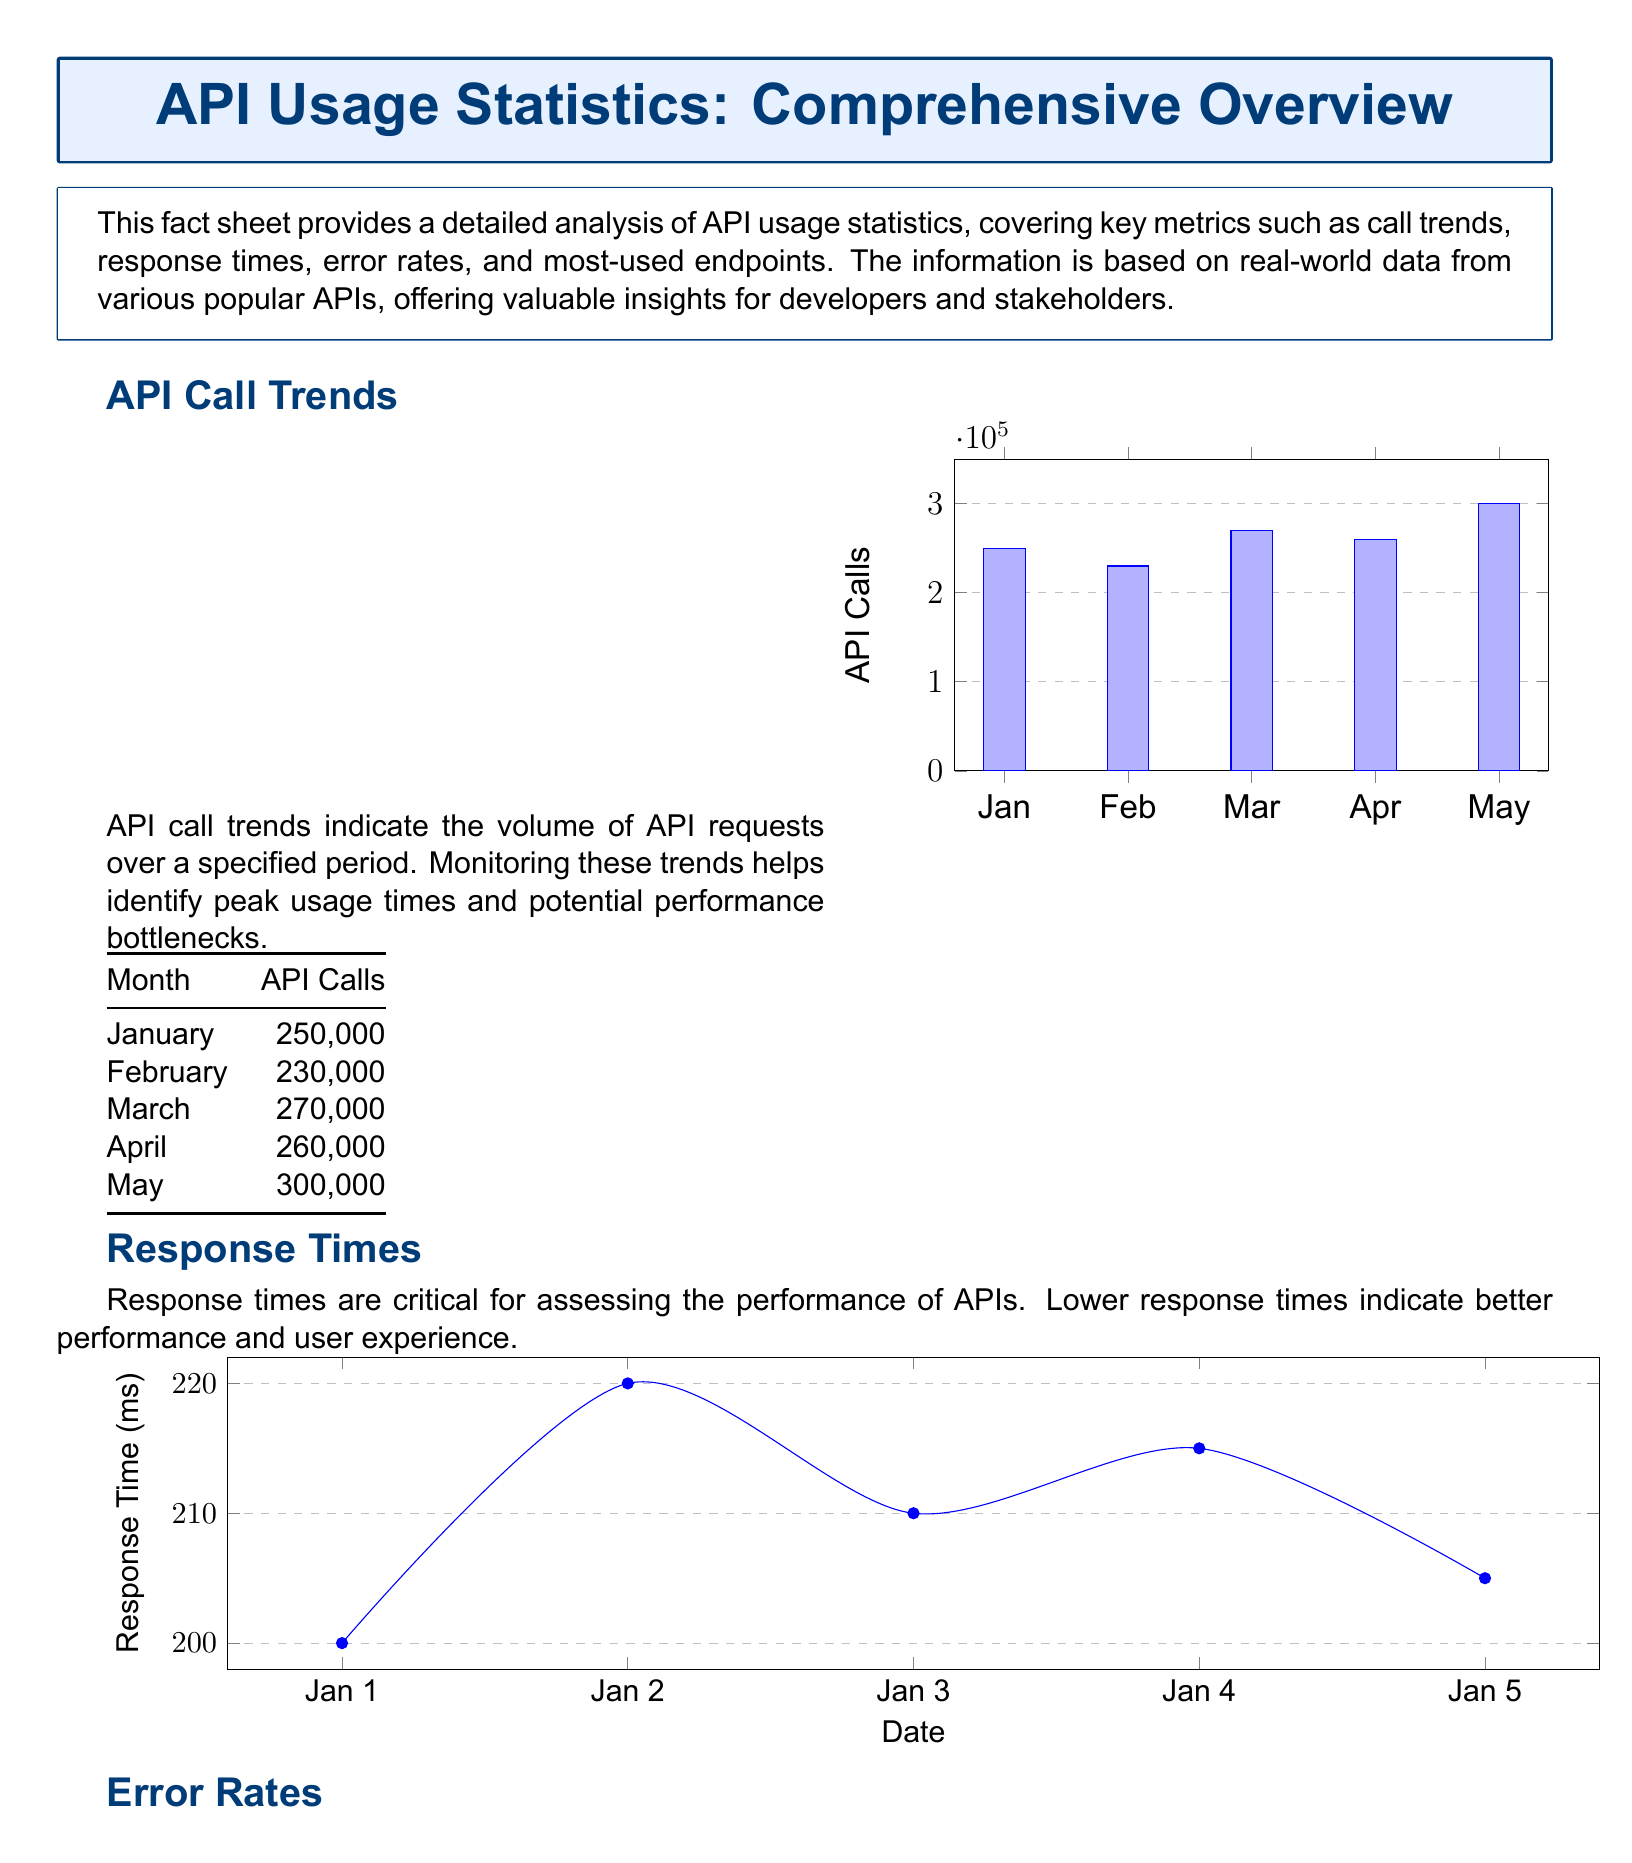What was the total number of API calls in May? The total number of API calls in May is directly shown in the table for that month, which is 300,000.
Answer: 300,000 What was the error rate in February? The error rate for February is provided in the error rates table, which states it is 1.5 percent.
Answer: 1.5 Which endpoint had the highest number of calls? The most-used endpoint is indicated in the table, listing "/user/login" with 90,000 calls.
Answer: /user/login What is the trend in API calls from January to May? The trend can be observed in the bar graph and data table, showing an increase overall, with May recording the highest.
Answer: Increasing What was the response time on January 3rd? The response time for January 3rd can be found in the response times line chart, which indicates 210 milliseconds.
Answer: 210 What was the error rate in April? The error rate for April is provided in the table, stating it is 1.1 percent.
Answer: 1.1 Which month had the lowest API call volume? The API call volume for February can be seen as the lowest in the trend table, with 230,000 calls.
Answer: February What are error rates compared between January and March? The error rates for January and March can be found in the table, where January's rate is 1.2, and March's rate is 1.3, indicating a slight increase.
Answer: Increased 